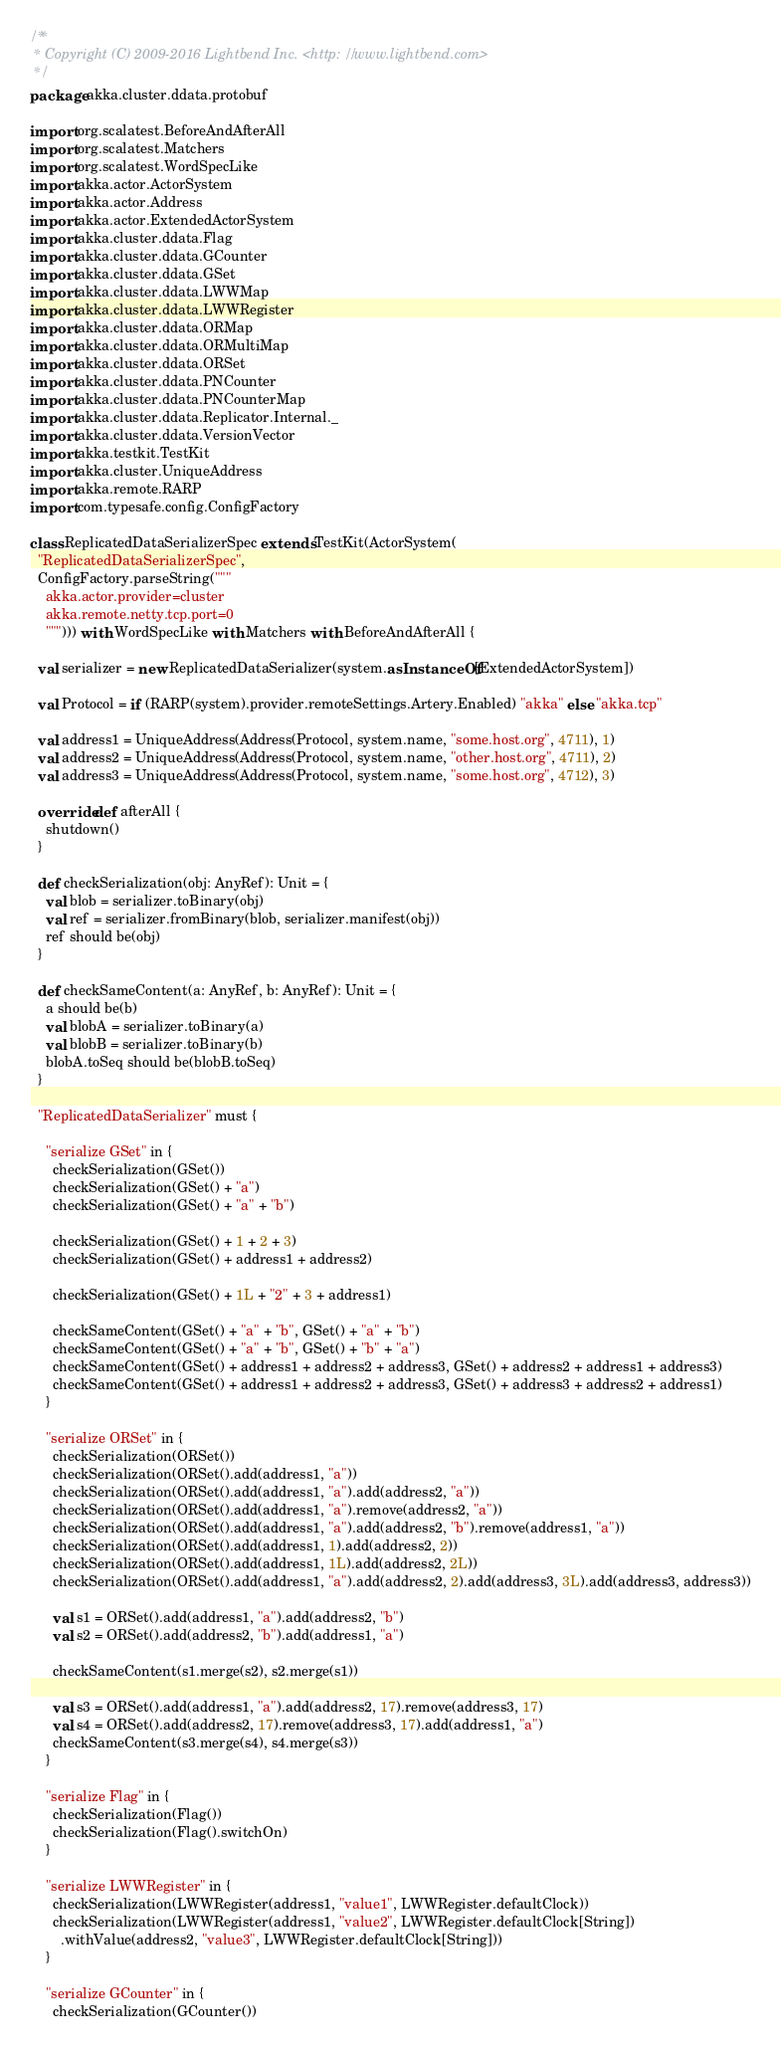<code> <loc_0><loc_0><loc_500><loc_500><_Scala_>/**
 * Copyright (C) 2009-2016 Lightbend Inc. <http://www.lightbend.com>
 */
package akka.cluster.ddata.protobuf

import org.scalatest.BeforeAndAfterAll
import org.scalatest.Matchers
import org.scalatest.WordSpecLike
import akka.actor.ActorSystem
import akka.actor.Address
import akka.actor.ExtendedActorSystem
import akka.cluster.ddata.Flag
import akka.cluster.ddata.GCounter
import akka.cluster.ddata.GSet
import akka.cluster.ddata.LWWMap
import akka.cluster.ddata.LWWRegister
import akka.cluster.ddata.ORMap
import akka.cluster.ddata.ORMultiMap
import akka.cluster.ddata.ORSet
import akka.cluster.ddata.PNCounter
import akka.cluster.ddata.PNCounterMap
import akka.cluster.ddata.Replicator.Internal._
import akka.cluster.ddata.VersionVector
import akka.testkit.TestKit
import akka.cluster.UniqueAddress
import akka.remote.RARP
import com.typesafe.config.ConfigFactory

class ReplicatedDataSerializerSpec extends TestKit(ActorSystem(
  "ReplicatedDataSerializerSpec",
  ConfigFactory.parseString("""
    akka.actor.provider=cluster
    akka.remote.netty.tcp.port=0
    """))) with WordSpecLike with Matchers with BeforeAndAfterAll {

  val serializer = new ReplicatedDataSerializer(system.asInstanceOf[ExtendedActorSystem])

  val Protocol = if (RARP(system).provider.remoteSettings.Artery.Enabled) "akka" else "akka.tcp"

  val address1 = UniqueAddress(Address(Protocol, system.name, "some.host.org", 4711), 1)
  val address2 = UniqueAddress(Address(Protocol, system.name, "other.host.org", 4711), 2)
  val address3 = UniqueAddress(Address(Protocol, system.name, "some.host.org", 4712), 3)

  override def afterAll {
    shutdown()
  }

  def checkSerialization(obj: AnyRef): Unit = {
    val blob = serializer.toBinary(obj)
    val ref = serializer.fromBinary(blob, serializer.manifest(obj))
    ref should be(obj)
  }

  def checkSameContent(a: AnyRef, b: AnyRef): Unit = {
    a should be(b)
    val blobA = serializer.toBinary(a)
    val blobB = serializer.toBinary(b)
    blobA.toSeq should be(blobB.toSeq)
  }

  "ReplicatedDataSerializer" must {

    "serialize GSet" in {
      checkSerialization(GSet())
      checkSerialization(GSet() + "a")
      checkSerialization(GSet() + "a" + "b")

      checkSerialization(GSet() + 1 + 2 + 3)
      checkSerialization(GSet() + address1 + address2)

      checkSerialization(GSet() + 1L + "2" + 3 + address1)

      checkSameContent(GSet() + "a" + "b", GSet() + "a" + "b")
      checkSameContent(GSet() + "a" + "b", GSet() + "b" + "a")
      checkSameContent(GSet() + address1 + address2 + address3, GSet() + address2 + address1 + address3)
      checkSameContent(GSet() + address1 + address2 + address3, GSet() + address3 + address2 + address1)
    }

    "serialize ORSet" in {
      checkSerialization(ORSet())
      checkSerialization(ORSet().add(address1, "a"))
      checkSerialization(ORSet().add(address1, "a").add(address2, "a"))
      checkSerialization(ORSet().add(address1, "a").remove(address2, "a"))
      checkSerialization(ORSet().add(address1, "a").add(address2, "b").remove(address1, "a"))
      checkSerialization(ORSet().add(address1, 1).add(address2, 2))
      checkSerialization(ORSet().add(address1, 1L).add(address2, 2L))
      checkSerialization(ORSet().add(address1, "a").add(address2, 2).add(address3, 3L).add(address3, address3))

      val s1 = ORSet().add(address1, "a").add(address2, "b")
      val s2 = ORSet().add(address2, "b").add(address1, "a")

      checkSameContent(s1.merge(s2), s2.merge(s1))

      val s3 = ORSet().add(address1, "a").add(address2, 17).remove(address3, 17)
      val s4 = ORSet().add(address2, 17).remove(address3, 17).add(address1, "a")
      checkSameContent(s3.merge(s4), s4.merge(s3))
    }

    "serialize Flag" in {
      checkSerialization(Flag())
      checkSerialization(Flag().switchOn)
    }

    "serialize LWWRegister" in {
      checkSerialization(LWWRegister(address1, "value1", LWWRegister.defaultClock))
      checkSerialization(LWWRegister(address1, "value2", LWWRegister.defaultClock[String])
        .withValue(address2, "value3", LWWRegister.defaultClock[String]))
    }

    "serialize GCounter" in {
      checkSerialization(GCounter())</code> 